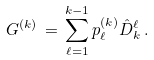<formula> <loc_0><loc_0><loc_500><loc_500>G ^ { ( k ) } \, = \, \sum _ { \ell = 1 } ^ { k - 1 } p _ { \ell } ^ { ( k ) } { \hat { D } } _ { k } ^ { \ell } \, .</formula> 